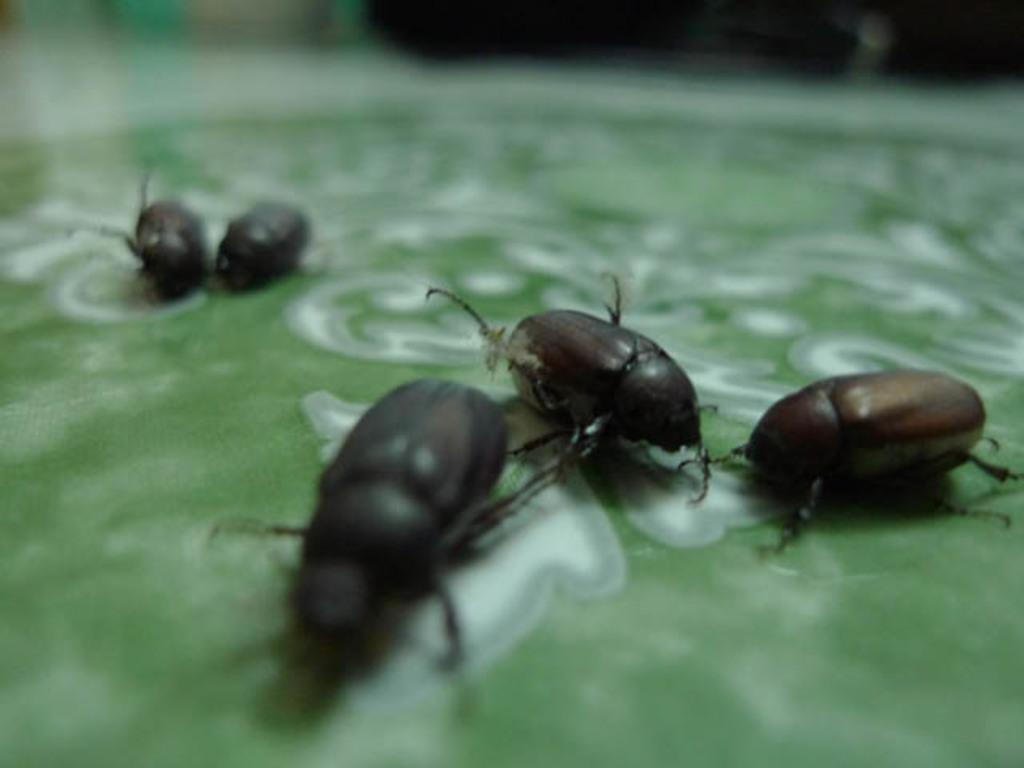What is the main subject of the picture? The main subject of the picture is a leaf. Are there any other living organisms on the leaf? Yes, there are bugs present on the leaf. What type of bucket can be seen in the picture? There is no bucket present in the picture; it only features a leaf with bugs on it. What stage of development are the bugs in the picture? The provided facts do not give information about the stage of development of the bugs, so it cannot be determined from the image. 